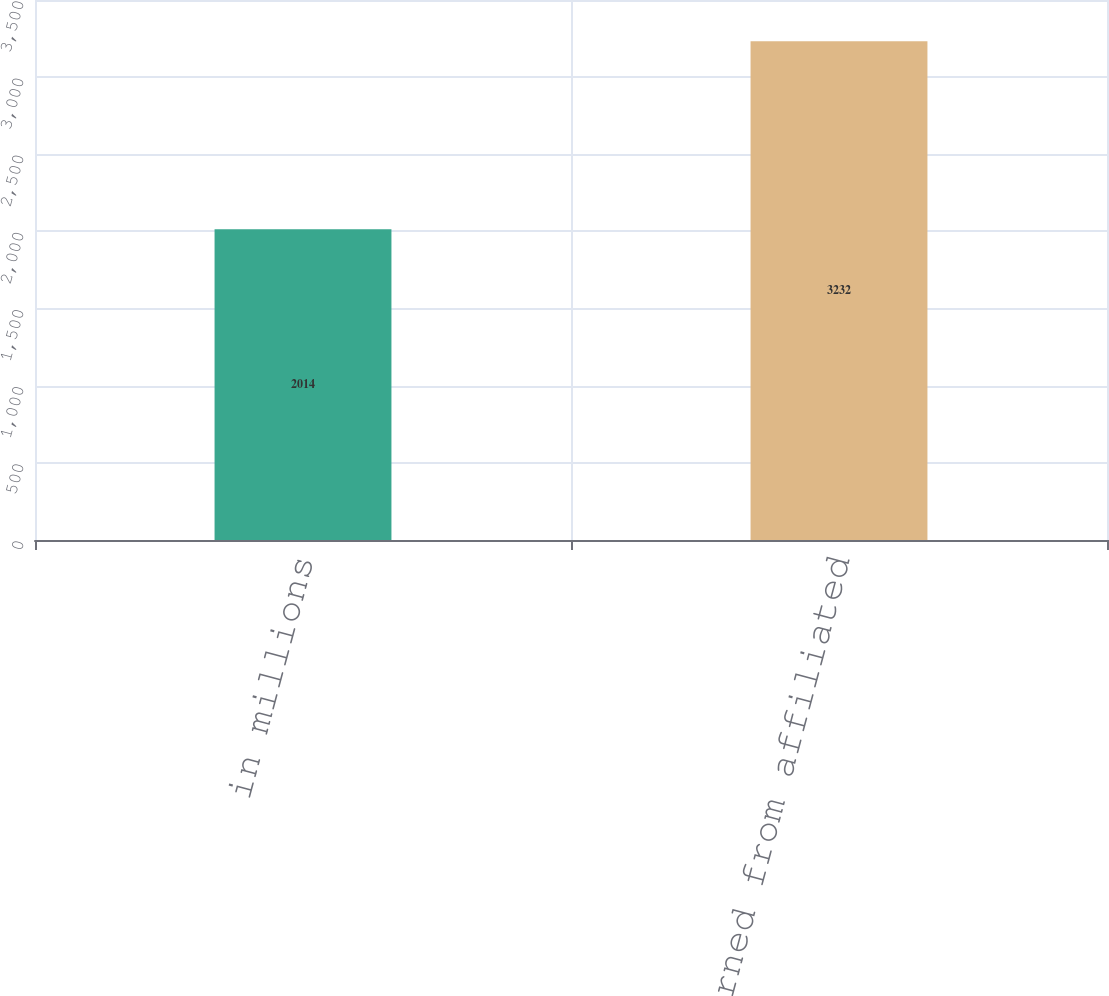Convert chart. <chart><loc_0><loc_0><loc_500><loc_500><bar_chart><fcel>in millions<fcel>Fees earned from affiliated<nl><fcel>2014<fcel>3232<nl></chart> 